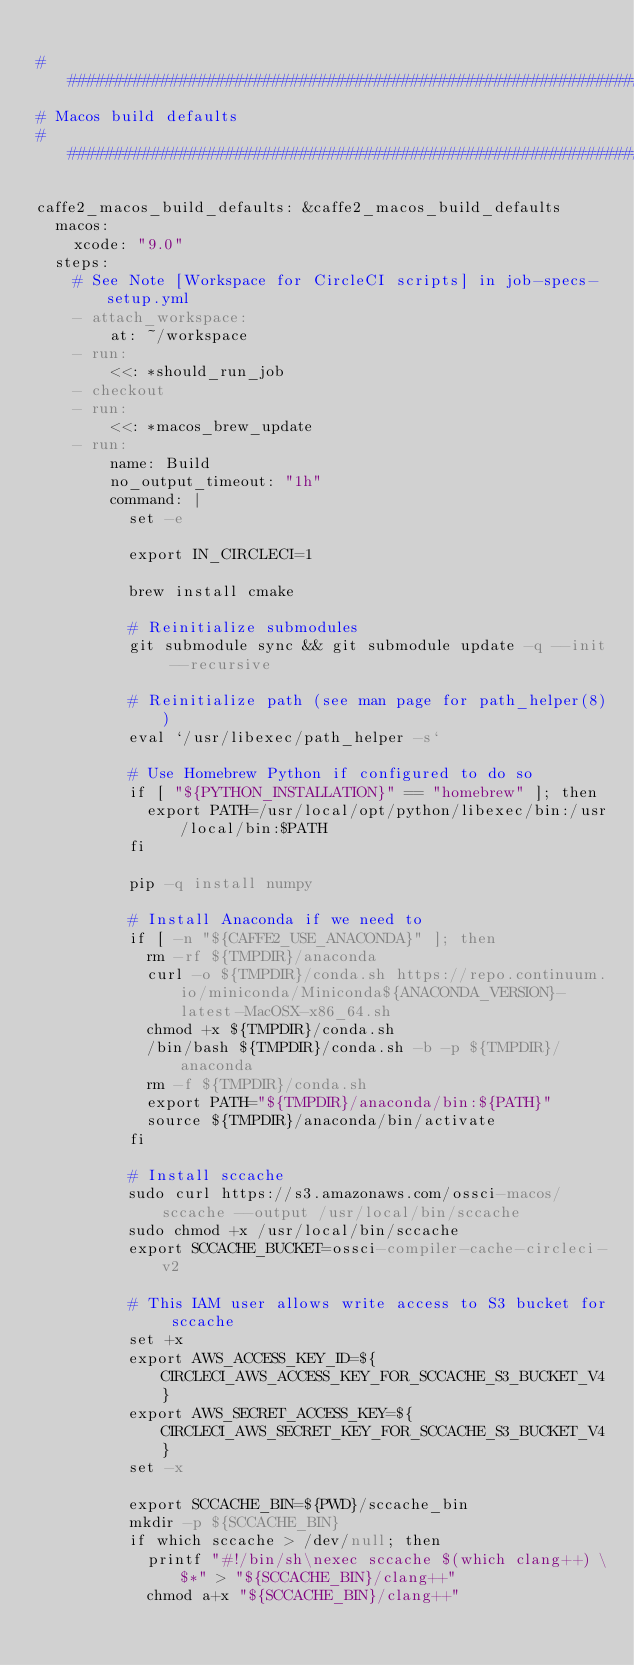<code> <loc_0><loc_0><loc_500><loc_500><_YAML_>
##############################################################################
# Macos build defaults
##############################################################################

caffe2_macos_build_defaults: &caffe2_macos_build_defaults
  macos:
    xcode: "9.0"
  steps:
    # See Note [Workspace for CircleCI scripts] in job-specs-setup.yml
    - attach_workspace:
        at: ~/workspace
    - run:
        <<: *should_run_job
    - checkout
    - run:
        <<: *macos_brew_update
    - run:
        name: Build
        no_output_timeout: "1h"
        command: |
          set -e

          export IN_CIRCLECI=1

          brew install cmake

          # Reinitialize submodules
          git submodule sync && git submodule update -q --init --recursive

          # Reinitialize path (see man page for path_helper(8))
          eval `/usr/libexec/path_helper -s`

          # Use Homebrew Python if configured to do so
          if [ "${PYTHON_INSTALLATION}" == "homebrew" ]; then
            export PATH=/usr/local/opt/python/libexec/bin:/usr/local/bin:$PATH
          fi

          pip -q install numpy

          # Install Anaconda if we need to
          if [ -n "${CAFFE2_USE_ANACONDA}" ]; then
            rm -rf ${TMPDIR}/anaconda
            curl -o ${TMPDIR}/conda.sh https://repo.continuum.io/miniconda/Miniconda${ANACONDA_VERSION}-latest-MacOSX-x86_64.sh
            chmod +x ${TMPDIR}/conda.sh
            /bin/bash ${TMPDIR}/conda.sh -b -p ${TMPDIR}/anaconda
            rm -f ${TMPDIR}/conda.sh
            export PATH="${TMPDIR}/anaconda/bin:${PATH}"
            source ${TMPDIR}/anaconda/bin/activate
          fi

          # Install sccache
          sudo curl https://s3.amazonaws.com/ossci-macos/sccache --output /usr/local/bin/sccache
          sudo chmod +x /usr/local/bin/sccache
          export SCCACHE_BUCKET=ossci-compiler-cache-circleci-v2

          # This IAM user allows write access to S3 bucket for sccache
          set +x
          export AWS_ACCESS_KEY_ID=${CIRCLECI_AWS_ACCESS_KEY_FOR_SCCACHE_S3_BUCKET_V4}
          export AWS_SECRET_ACCESS_KEY=${CIRCLECI_AWS_SECRET_KEY_FOR_SCCACHE_S3_BUCKET_V4}
          set -x

          export SCCACHE_BIN=${PWD}/sccache_bin
          mkdir -p ${SCCACHE_BIN}
          if which sccache > /dev/null; then
            printf "#!/bin/sh\nexec sccache $(which clang++) \$*" > "${SCCACHE_BIN}/clang++"
            chmod a+x "${SCCACHE_BIN}/clang++"
</code> 